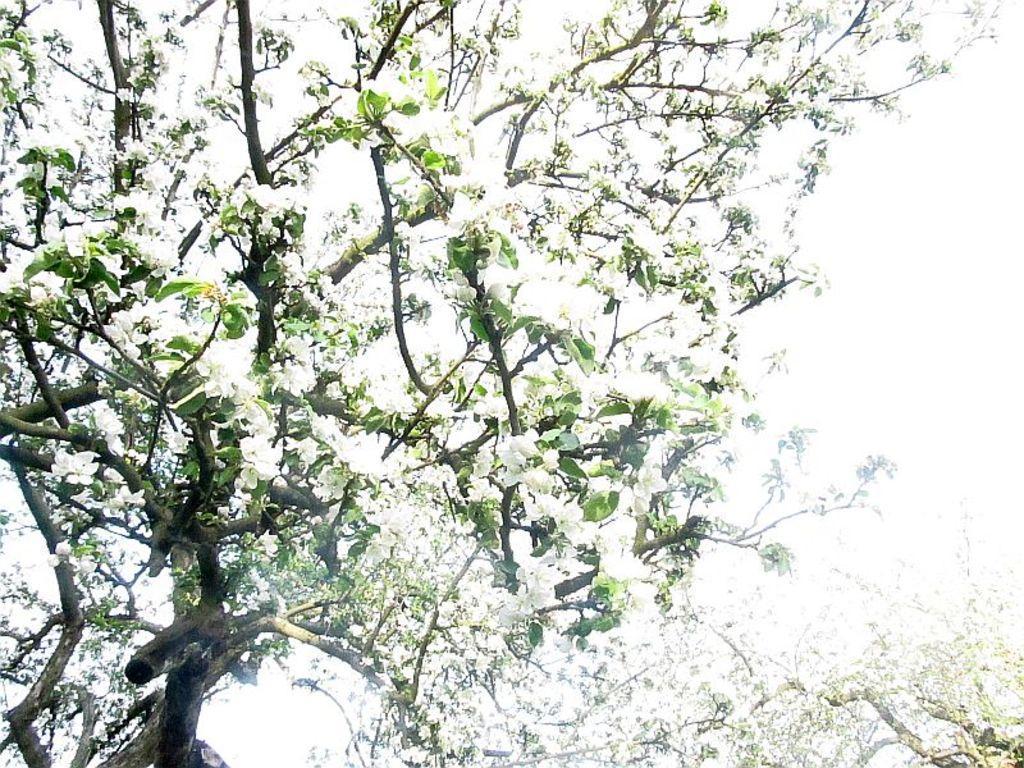Can you describe this image briefly? In the center of the image there are trees and we can see blossoms. In the background there is sky. 